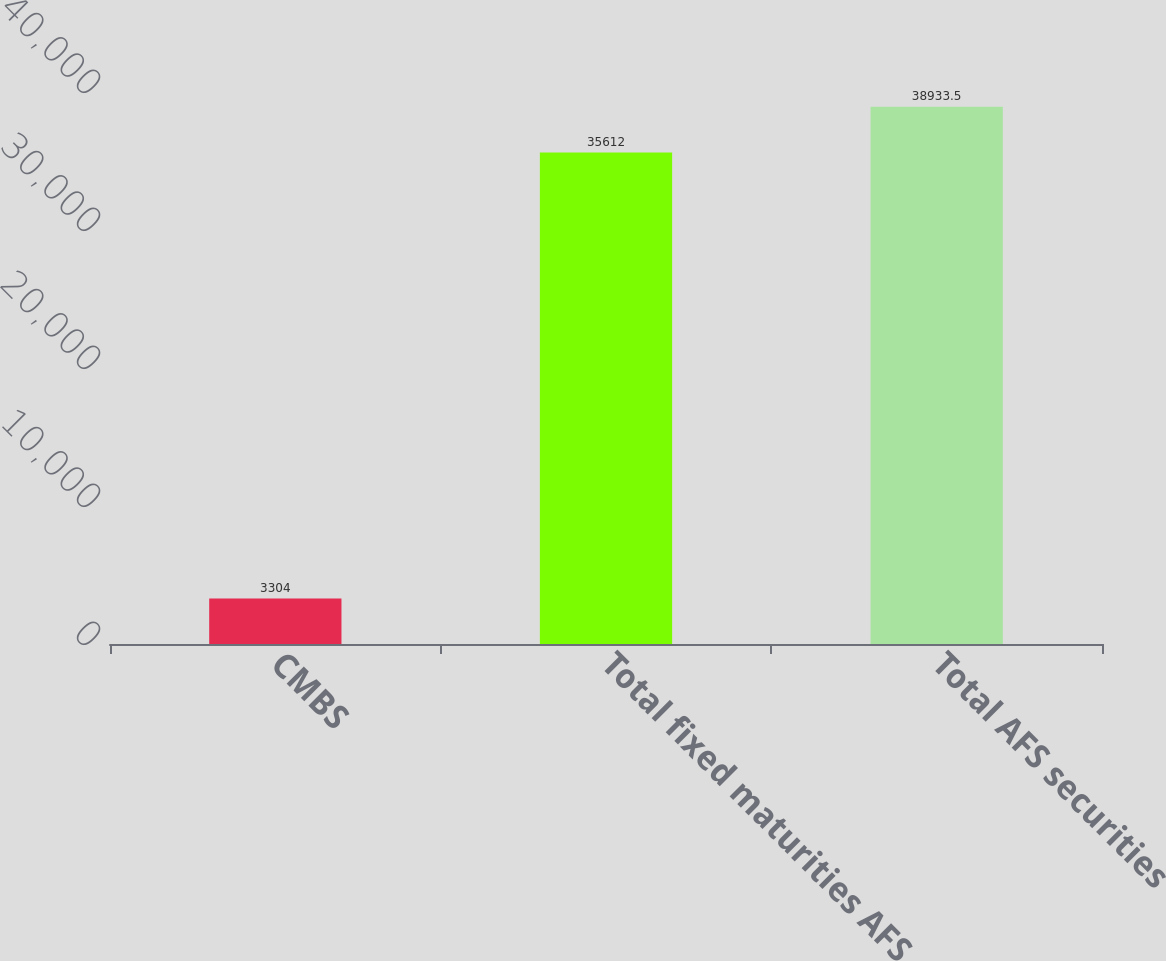<chart> <loc_0><loc_0><loc_500><loc_500><bar_chart><fcel>CMBS<fcel>Total fixed maturities AFS<fcel>Total AFS securities<nl><fcel>3304<fcel>35612<fcel>38933.5<nl></chart> 